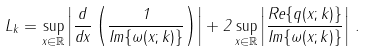<formula> <loc_0><loc_0><loc_500><loc_500>L _ { k } = \sup _ { x \in \mathbb { R } } \left | \frac { d } { d x } \left ( \frac { 1 } { I m \{ \omega ( x ; k ) \} } \right ) \right | + 2 \sup _ { x \in \mathbb { R } } \left | \frac { R e \{ q ( x ; k ) \} } { I m \{ \omega ( x ; k ) \} } \right | \, .</formula> 